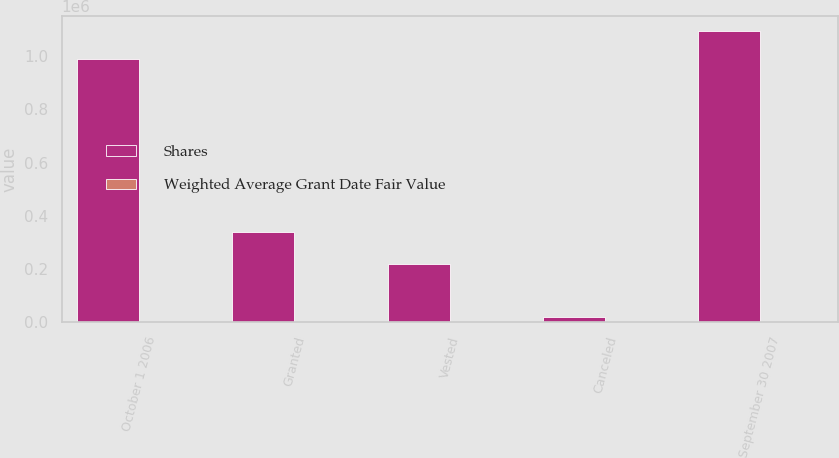Convert chart. <chart><loc_0><loc_0><loc_500><loc_500><stacked_bar_chart><ecel><fcel>October 1 2006<fcel>Granted<fcel>Vested<fcel>Canceled<fcel>September 30 2007<nl><fcel>Shares<fcel>989946<fcel>339969<fcel>217145<fcel>16989<fcel>1.09578e+06<nl><fcel>Weighted Average Grant Date Fair Value<fcel>21.49<fcel>30.73<fcel>16.75<fcel>25.06<fcel>25.24<nl></chart> 